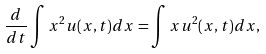Convert formula to latex. <formula><loc_0><loc_0><loc_500><loc_500>\frac { d } { d t } \int x ^ { 2 } u ( x , t ) d x = \int x u ^ { 2 } ( x , t ) d x ,</formula> 